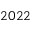<formula> <loc_0><loc_0><loc_500><loc_500>2 0 2 2</formula> 